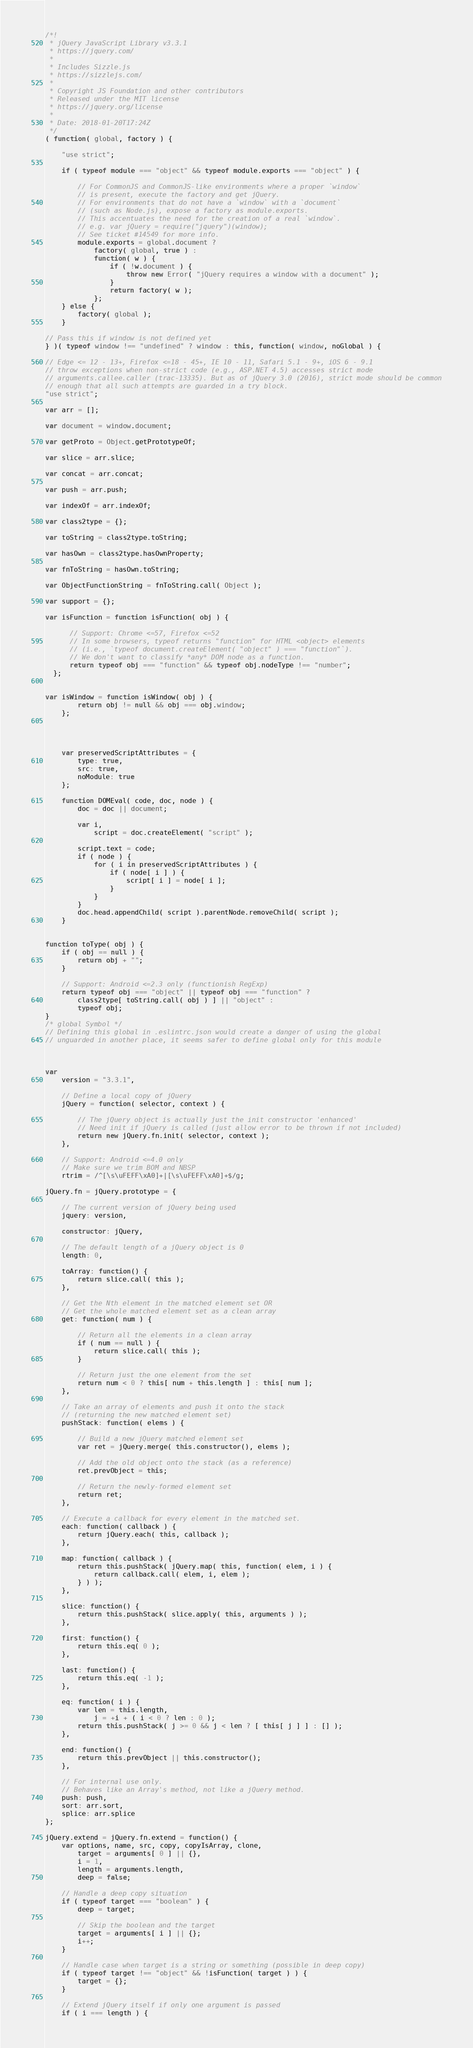Convert code to text. <code><loc_0><loc_0><loc_500><loc_500><_JavaScript_>/*!
 * jQuery JavaScript Library v3.3.1
 * https://jquery.com/
 *
 * Includes Sizzle.js
 * https://sizzlejs.com/
 *
 * Copyright JS Foundation and other contributors
 * Released under the MIT license
 * https://jquery.org/license
 *
 * Date: 2018-01-20T17:24Z
 */
( function( global, factory ) {

	"use strict";

	if ( typeof module === "object" && typeof module.exports === "object" ) {

		// For CommonJS and CommonJS-like environments where a proper `window`
		// is present, execute the factory and get jQuery.
		// For environments that do not have a `window` with a `document`
		// (such as Node.js), expose a factory as module.exports.
		// This accentuates the need for the creation of a real `window`.
		// e.g. var jQuery = require("jquery")(window);
		// See ticket #14549 for more info.
		module.exports = global.document ?
			factory( global, true ) :
			function( w ) {
				if ( !w.document ) {
					throw new Error( "jQuery requires a window with a document" );
				}
				return factory( w );
			};
	} else {
		factory( global );
	}

// Pass this if window is not defined yet
} )( typeof window !== "undefined" ? window : this, function( window, noGlobal ) {

// Edge <= 12 - 13+, Firefox <=18 - 45+, IE 10 - 11, Safari 5.1 - 9+, iOS 6 - 9.1
// throw exceptions when non-strict code (e.g., ASP.NET 4.5) accesses strict mode
// arguments.callee.caller (trac-13335). But as of jQuery 3.0 (2016), strict mode should be common
// enough that all such attempts are guarded in a try block.
"use strict";

var arr = [];

var document = window.document;

var getProto = Object.getPrototypeOf;

var slice = arr.slice;

var concat = arr.concat;

var push = arr.push;

var indexOf = arr.indexOf;

var class2type = {};

var toString = class2type.toString;

var hasOwn = class2type.hasOwnProperty;

var fnToString = hasOwn.toString;

var ObjectFunctionString = fnToString.call( Object );

var support = {};

var isFunction = function isFunction( obj ) {

      // Support: Chrome <=57, Firefox <=52
      // In some browsers, typeof returns "function" for HTML <object> elements
      // (i.e., `typeof document.createElement( "object" ) === "function"`).
      // We don't want to classify *any* DOM node as a function.
      return typeof obj === "function" && typeof obj.nodeType !== "number";
  };


var isWindow = function isWindow( obj ) {
		return obj != null && obj === obj.window;
	};




	var preservedScriptAttributes = {
		type: true,
		src: true,
		noModule: true
	};

	function DOMEval( code, doc, node ) {
		doc = doc || document;

		var i,
			script = doc.createElement( "script" );

		script.text = code;
		if ( node ) {
			for ( i in preservedScriptAttributes ) {
				if ( node[ i ] ) {
					script[ i ] = node[ i ];
				}
			}
		}
		doc.head.appendChild( script ).parentNode.removeChild( script );
	}


function toType( obj ) {
	if ( obj == null ) {
		return obj + "";
	}

	// Support: Android <=2.3 only (functionish RegExp)
	return typeof obj === "object" || typeof obj === "function" ?
		class2type[ toString.call( obj ) ] || "object" :
		typeof obj;
}
/* global Symbol */
// Defining this global in .eslintrc.json would create a danger of using the global
// unguarded in another place, it seems safer to define global only for this module



var
	version = "3.3.1",

	// Define a local copy of jQuery
	jQuery = function( selector, context ) {

		// The jQuery object is actually just the init constructor 'enhanced'
		// Need init if jQuery is called (just allow error to be thrown if not included)
		return new jQuery.fn.init( selector, context );
	},

	// Support: Android <=4.0 only
	// Make sure we trim BOM and NBSP
	rtrim = /^[\s\uFEFF\xA0]+|[\s\uFEFF\xA0]+$/g;

jQuery.fn = jQuery.prototype = {

	// The current version of jQuery being used
	jquery: version,

	constructor: jQuery,

	// The default length of a jQuery object is 0
	length: 0,

	toArray: function() {
		return slice.call( this );
	},

	// Get the Nth element in the matched element set OR
	// Get the whole matched element set as a clean array
	get: function( num ) {

		// Return all the elements in a clean array
		if ( num == null ) {
			return slice.call( this );
		}

		// Return just the one element from the set
		return num < 0 ? this[ num + this.length ] : this[ num ];
	},

	// Take an array of elements and push it onto the stack
	// (returning the new matched element set)
	pushStack: function( elems ) {

		// Build a new jQuery matched element set
		var ret = jQuery.merge( this.constructor(), elems );

		// Add the old object onto the stack (as a reference)
		ret.prevObject = this;

		// Return the newly-formed element set
		return ret;
	},

	// Execute a callback for every element in the matched set.
	each: function( callback ) {
		return jQuery.each( this, callback );
	},

	map: function( callback ) {
		return this.pushStack( jQuery.map( this, function( elem, i ) {
			return callback.call( elem, i, elem );
		} ) );
	},

	slice: function() {
		return this.pushStack( slice.apply( this, arguments ) );
	},

	first: function() {
		return this.eq( 0 );
	},

	last: function() {
		return this.eq( -1 );
	},

	eq: function( i ) {
		var len = this.length,
			j = +i + ( i < 0 ? len : 0 );
		return this.pushStack( j >= 0 && j < len ? [ this[ j ] ] : [] );
	},

	end: function() {
		return this.prevObject || this.constructor();
	},

	// For internal use only.
	// Behaves like an Array's method, not like a jQuery method.
	push: push,
	sort: arr.sort,
	splice: arr.splice
};

jQuery.extend = jQuery.fn.extend = function() {
	var options, name, src, copy, copyIsArray, clone,
		target = arguments[ 0 ] || {},
		i = 1,
		length = arguments.length,
		deep = false;

	// Handle a deep copy situation
	if ( typeof target === "boolean" ) {
		deep = target;

		// Skip the boolean and the target
		target = arguments[ i ] || {};
		i++;
	}

	// Handle case when target is a string or something (possible in deep copy)
	if ( typeof target !== "object" && !isFunction( target ) ) {
		target = {};
	}

	// Extend jQuery itself if only one argument is passed
	if ( i === length ) {</code> 